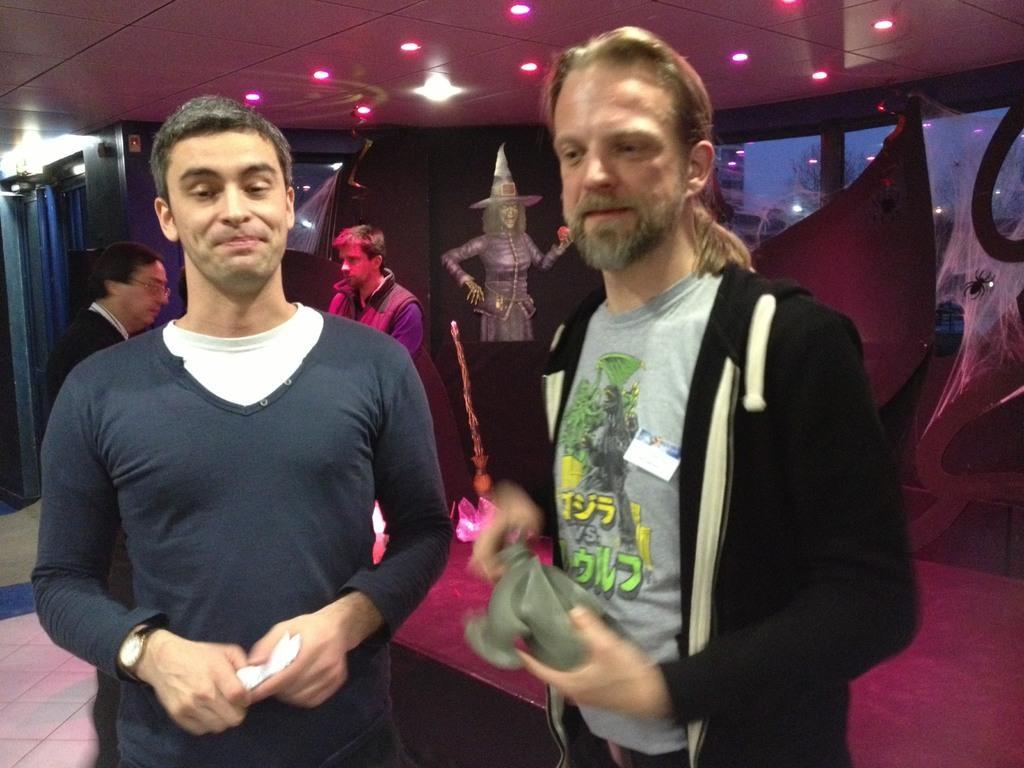Could you give a brief overview of what you see in this image? The picture is clicked in a room. In the foreground of the picture there are two man standing. On the right the man is wearing a black hoodie. On the left the man is wearing a blue t-shirt. In the background there are people standing. On the left there are lights and curtains. At the top there are lights to the ceiling. On the right there is a glass window, outside the window there are trees and buildings. In the center of the background there is a painting on the wall. 